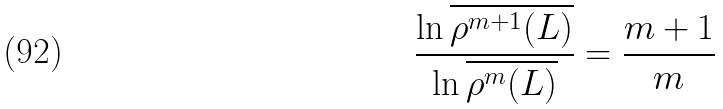Convert formula to latex. <formula><loc_0><loc_0><loc_500><loc_500>\frac { \ln \overline { \rho ^ { m + 1 } ( L ) } } { \ln \overline { \rho ^ { m } ( L ) } } = \frac { m + 1 } { m }</formula> 